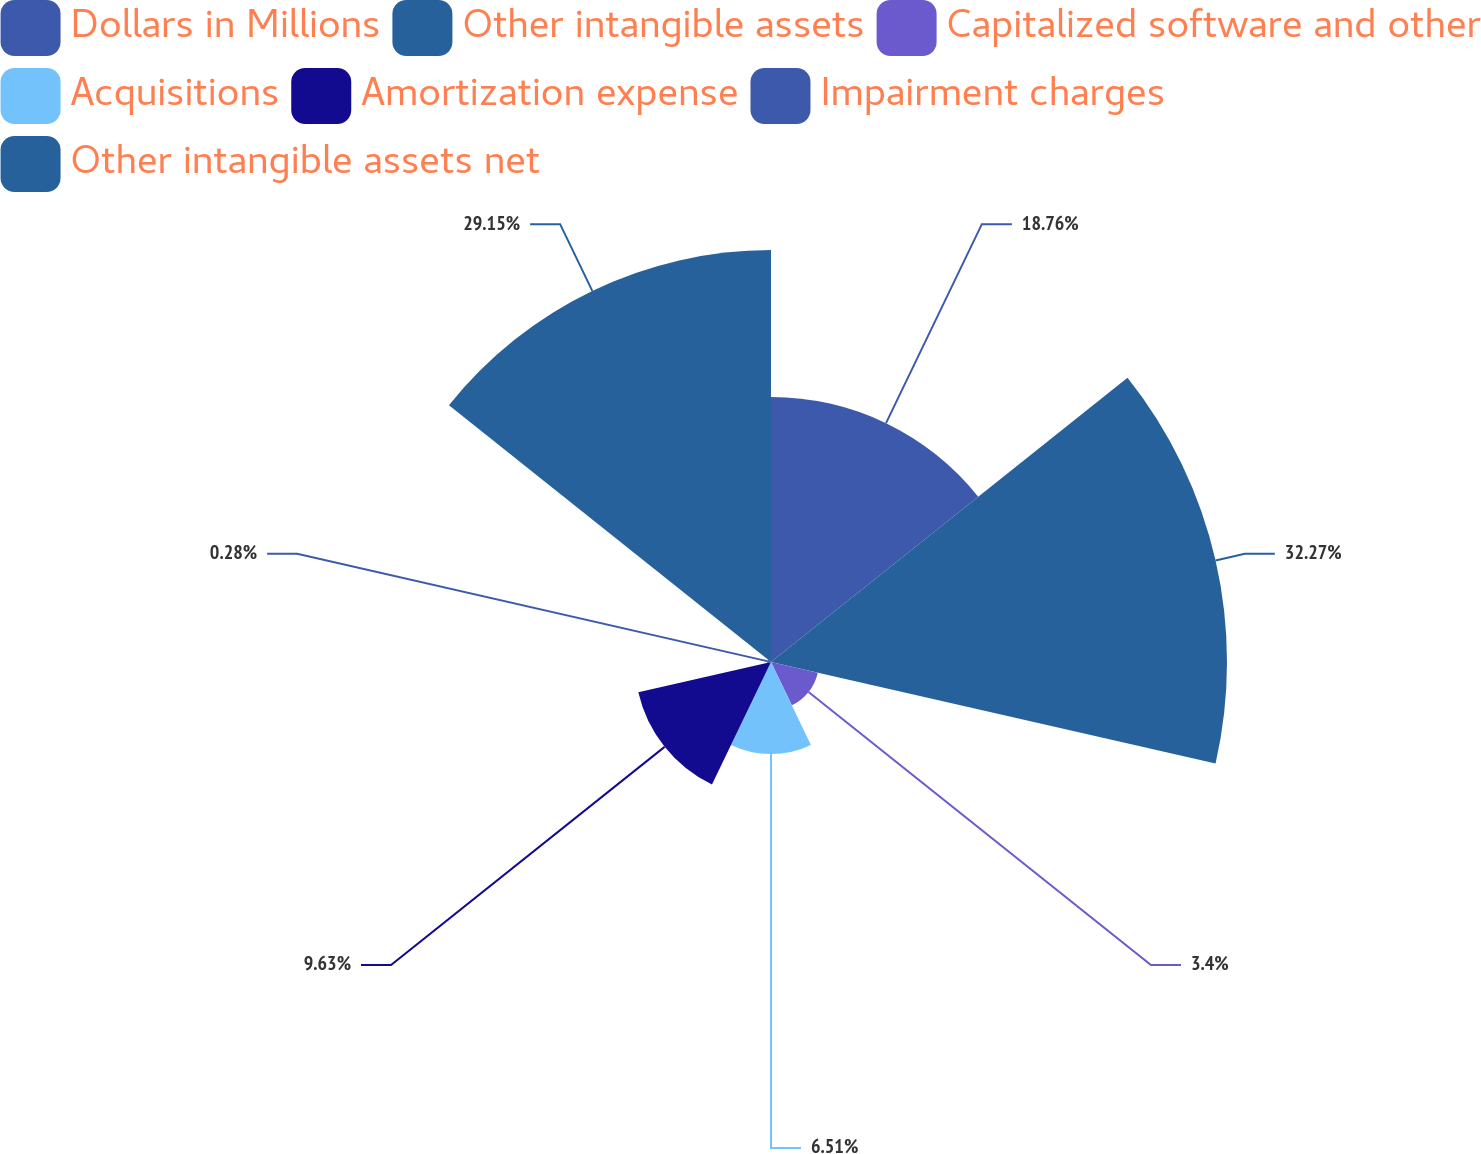Convert chart. <chart><loc_0><loc_0><loc_500><loc_500><pie_chart><fcel>Dollars in Millions<fcel>Other intangible assets<fcel>Capitalized software and other<fcel>Acquisitions<fcel>Amortization expense<fcel>Impairment charges<fcel>Other intangible assets net<nl><fcel>18.76%<fcel>32.27%<fcel>3.4%<fcel>6.51%<fcel>9.63%<fcel>0.28%<fcel>29.15%<nl></chart> 